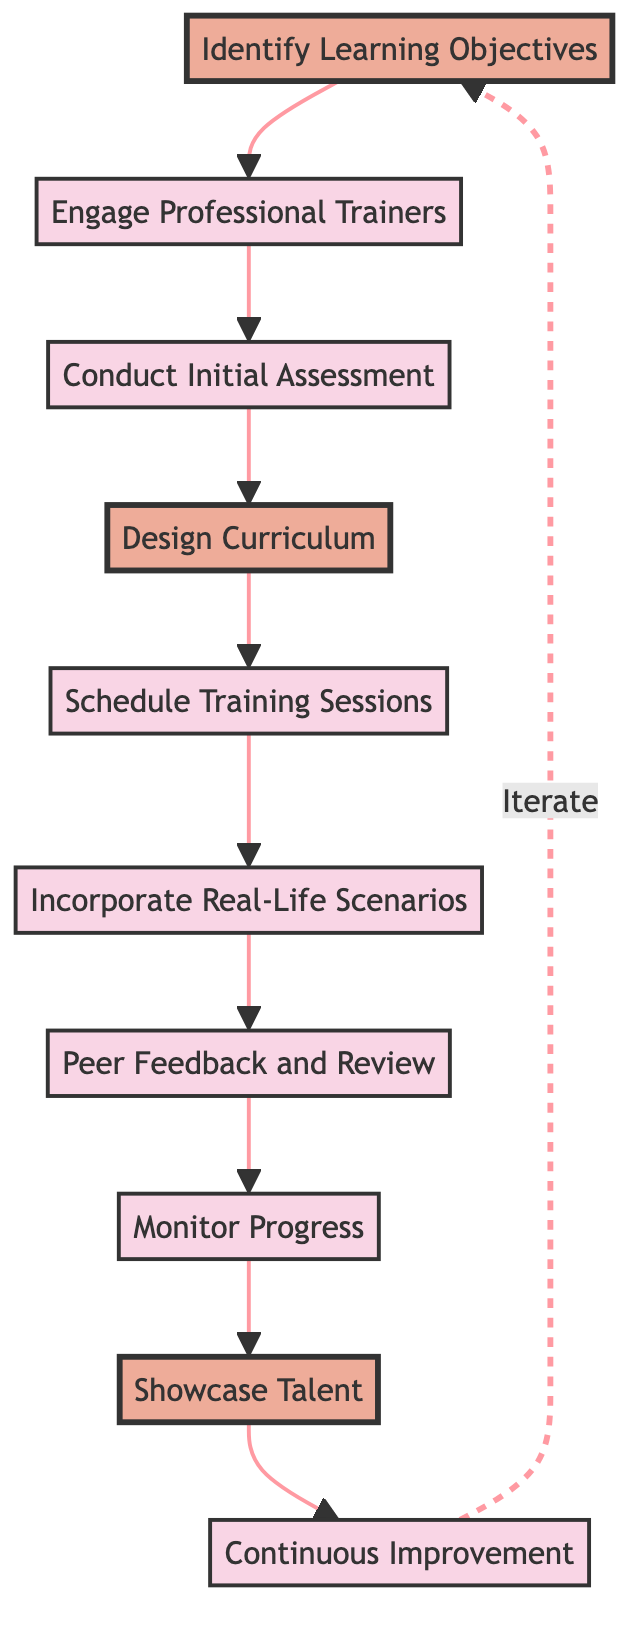What is the first step in the process? The diagram shows "Identify Learning Objectives" as the first step, which is the starting point of the flowchart.
Answer: Identify Learning Objectives How many steps are in the diagram? By counting the nodes in the diagram, there are a total of ten steps indicated by the numbered elements.
Answer: 10 What comes after "Engage Professional Trainers"? Following the arrow from "Engage Professional Trainers," the next step in the flowchart is "Conduct Initial Assessment."
Answer: Conduct Initial Assessment What is the last step in the flow? At the end of the flowchart, "Continuous Improvement" is shown as the last step before it loops back to "Identify Learning Objectives."
Answer: Continuous Improvement Which step includes performances? "Showcase Talent" is the step in the process that specifically mentions organizing events for performances.
Answer: Showcase Talent How many highlighted steps are there? The diagram highlights three specific steps: "Identify Learning Objectives," "Design Curriculum," and "Showcase Talent," which can be counted for a total.
Answer: 3 What is the relationship between "Peer Feedback and Review" and "Monitor Progress"? "Peer Feedback and Review" leads directly to "Monitor Progress," indicating a sequential relationship between these two steps in the process.
Answer: Directly leads to What happens after "Monitor Progress"? The flow continues from "Monitor Progress" to "Showcase Talent," indicating the next step in the training program.
Answer: Showcase Talent What role does "Incorporate Real-Life Scenarios" play in the sequence? It serves as a step that comes after "Schedule Training Sessions" and emphasizes applying skills to realistic customer interactions.
Answer: Skill application in context How does the flowchart depict improvement? The flowchart illustrates continuous improvement by returning to "Identify Learning Objectives" after "Continuous Improvement," suggesting an iterative process.
Answer: Iterative process 